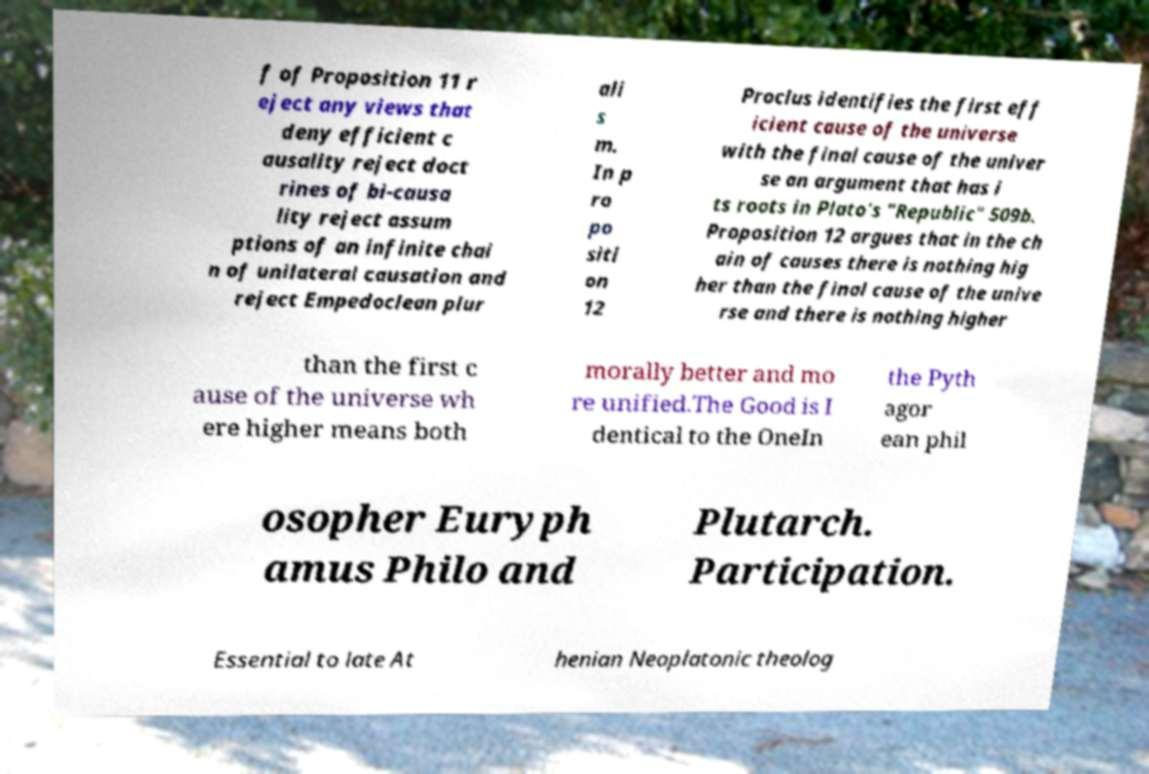Can you read and provide the text displayed in the image?This photo seems to have some interesting text. Can you extract and type it out for me? f of Proposition 11 r eject any views that deny efficient c ausality reject doct rines of bi-causa lity reject assum ptions of an infinite chai n of unilateral causation and reject Empedoclean plur ali s m. In p ro po siti on 12 Proclus identifies the first eff icient cause of the universe with the final cause of the univer se an argument that has i ts roots in Plato's "Republic" 509b. Proposition 12 argues that in the ch ain of causes there is nothing hig her than the final cause of the unive rse and there is nothing higher than the first c ause of the universe wh ere higher means both morally better and mo re unified.The Good is I dentical to the OneIn the Pyth agor ean phil osopher Euryph amus Philo and Plutarch. Participation. Essential to late At henian Neoplatonic theolog 